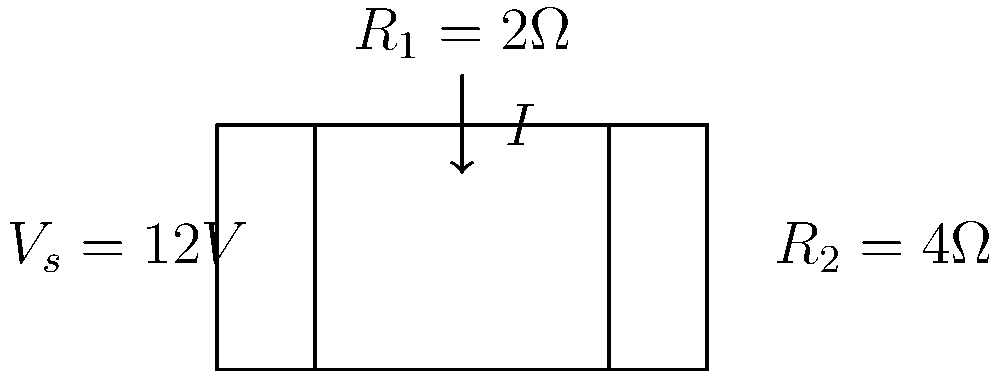Given the series circuit shown in the diagram, where $V_s = 12V$, $R_1 = 2\Omega$, and $R_2 = 4\Omega$, calculate the voltage drop across resistor $R_1$. Express your answer in volts. To solve this problem, we'll follow these steps:

1) First, calculate the total resistance of the circuit:
   $R_{total} = R_1 + R_2 = 2\Omega + 4\Omega = 6\Omega$

2) Use Ohm's Law to find the current in the circuit:
   $I = \frac{V_s}{R_{total}} = \frac{12V}{6\Omega} = 2A$

3) Now, use Ohm's Law again to find the voltage drop across $R_1$:
   $V_{R1} = I \times R_1 = 2A \times 2\Omega = 4V$

Therefore, the voltage drop across resistor $R_1$ is 4 volts.
Answer: $4V$ 